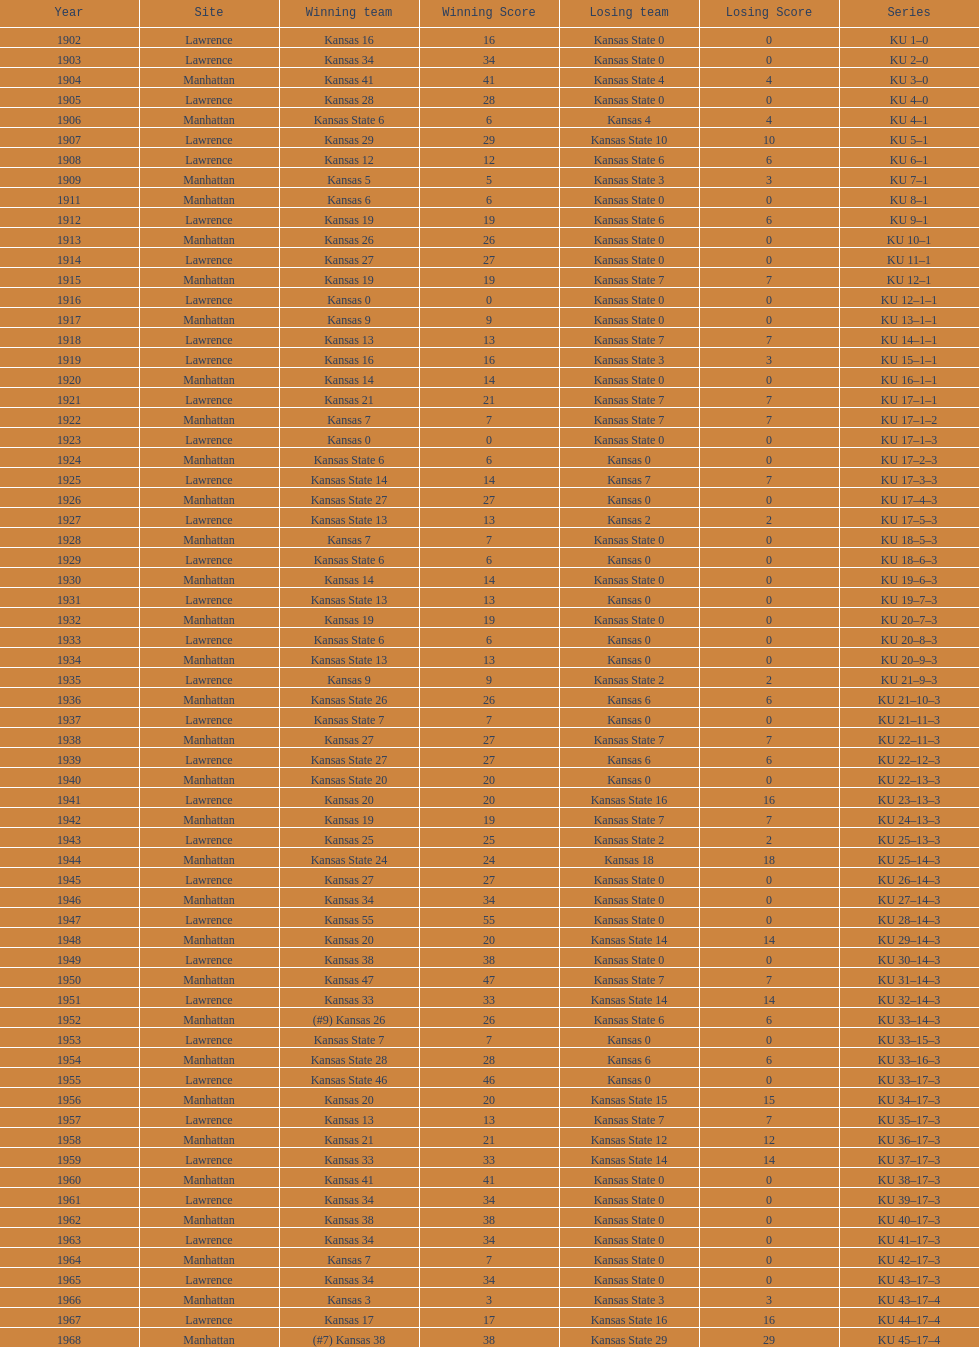How many times did kansas state not score at all against kansas from 1902-1968? 23. 